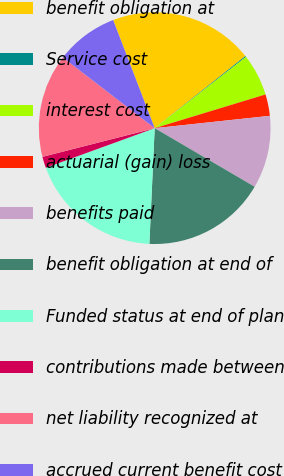Convert chart. <chart><loc_0><loc_0><loc_500><loc_500><pie_chart><fcel>benefit obligation at<fcel>Service cost<fcel>interest cost<fcel>actuarial (gain) loss<fcel>benefits paid<fcel>benefit obligation at end of<fcel>Funded status at end of plan<fcel>contributions made between<fcel>net liability recognized at<fcel>accrued current benefit cost<nl><fcel>20.15%<fcel>0.14%<fcel>5.85%<fcel>3.0%<fcel>10.14%<fcel>17.29%<fcel>18.72%<fcel>1.57%<fcel>14.43%<fcel>8.71%<nl></chart> 